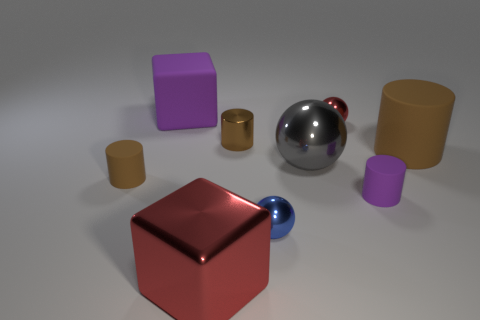Subtract all brown cylinders. How many were subtracted if there are1brown cylinders left? 2 Subtract all small blue spheres. How many spheres are left? 2 Add 1 large purple cubes. How many objects exist? 10 Subtract all purple cylinders. How many cylinders are left? 3 Subtract all cyan cubes. How many brown cylinders are left? 3 Subtract 1 cubes. How many cubes are left? 1 Subtract all cylinders. How many objects are left? 5 Subtract all brown blocks. Subtract all brown cylinders. How many blocks are left? 2 Subtract all matte objects. Subtract all big brown objects. How many objects are left? 4 Add 1 purple matte things. How many purple matte things are left? 3 